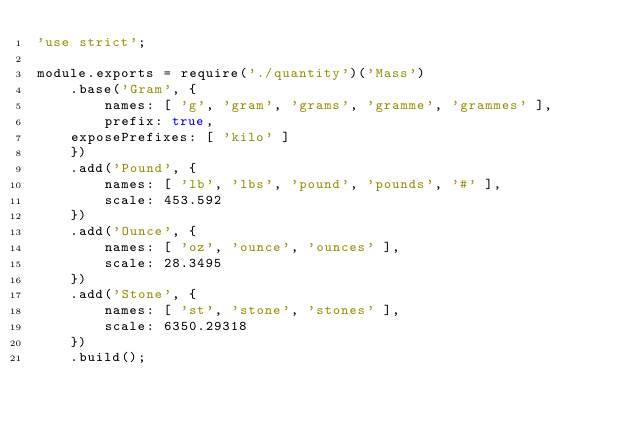<code> <loc_0><loc_0><loc_500><loc_500><_JavaScript_>'use strict';

module.exports = require('./quantity')('Mass')
    .base('Gram', {
        names: [ 'g', 'gram', 'grams', 'gramme', 'grammes' ],
        prefix: true,
		exposePrefixes: [ 'kilo' ]
    })
    .add('Pound', {
        names: [ 'lb', 'lbs', 'pound', 'pounds', '#' ],
        scale: 453.592
    })
    .add('Ounce', {
        names: [ 'oz', 'ounce', 'ounces' ],
        scale: 28.3495
    })
    .add('Stone', {
        names: [ 'st', 'stone', 'stones' ],
        scale: 6350.29318
    })
    .build();
</code> 